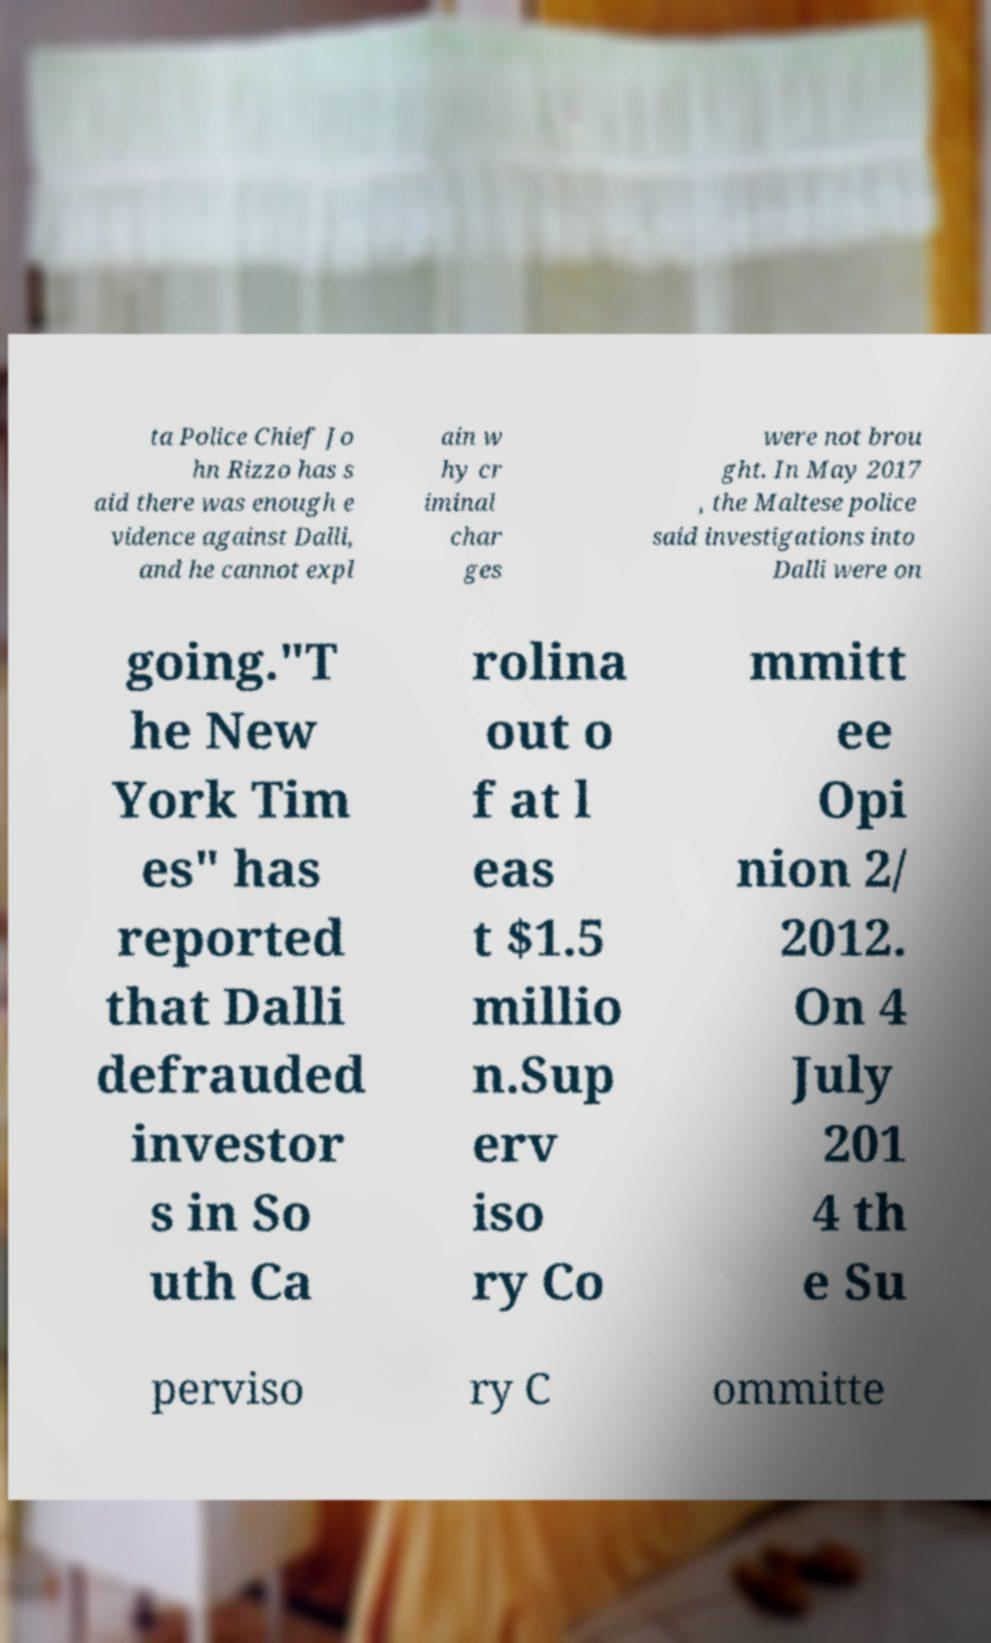Could you extract and type out the text from this image? ta Police Chief Jo hn Rizzo has s aid there was enough e vidence against Dalli, and he cannot expl ain w hy cr iminal char ges were not brou ght. In May 2017 , the Maltese police said investigations into Dalli were on going."T he New York Tim es" has reported that Dalli defrauded investor s in So uth Ca rolina out o f at l eas t $1.5 millio n.Sup erv iso ry Co mmitt ee Opi nion 2/ 2012. On 4 July 201 4 th e Su perviso ry C ommitte 